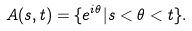Convert formula to latex. <formula><loc_0><loc_0><loc_500><loc_500>A ( s , t ) = \{ e ^ { i \theta } | s < \theta < t \} .</formula> 